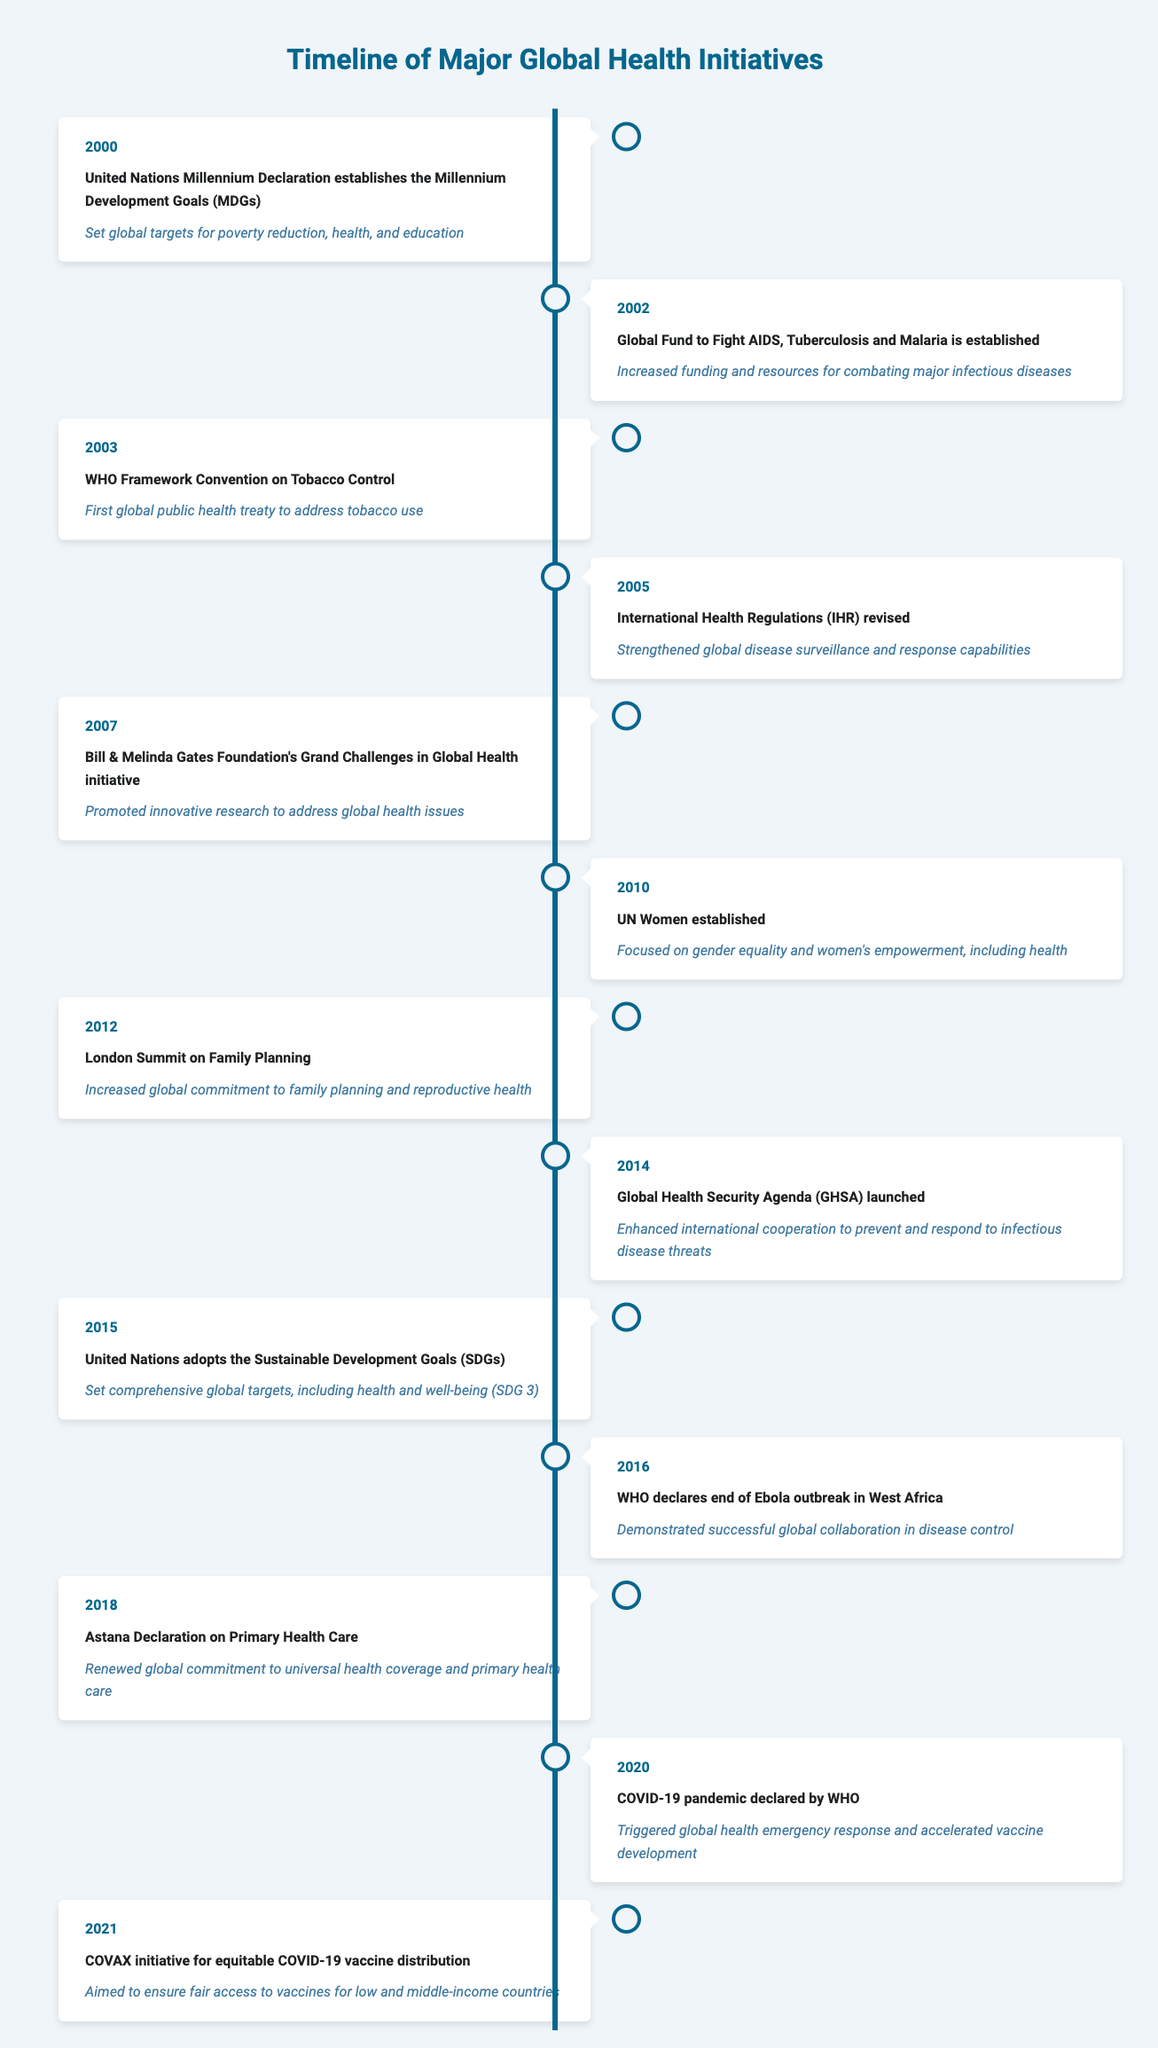What major global health initiative was established in 2000? The table indicates that in 2000, the "United Nations Millennium Declaration establishes the Millennium Development Goals (MDGs)" as a major global health initiative.
Answer: United Nations Millennium Declaration establishes the Millennium Development Goals (MDGs) What impact did the Global Fund to Fight AIDS, Tuberculosis and Malaria have? According to the entry for 2002, the impact was "Increased funding and resources for combating major infectious diseases."
Answer: Increased funding and resources for combating major infectious diseases In what year did the WHO declare the end of the Ebola outbreak? The table shows that the WHO declared the end of the Ebola outbreak in West Africa in 2016.
Answer: 2016 True or False: The Global Health Security Agenda was launched in 2012. The table states the Global Health Security Agenda was launched in 2014, therefore the statement is false.
Answer: False What is the difference in years between the establishment of UN Women and the establishment of the Global Fund? UN Women was established in 2010 and the Global Fund was established in 2002. The difference is 2010 - 2002 = 8 years.
Answer: 8 years How many major global health initiatives were established between 2000 and 2015? There are 8 initiatives listed between the years 2000 and 2015 (including events from 2000 to 2015), which can be counted directly from the rows.
Answer: 8 What is the impact of the Astana Declaration on Primary Health Care? The table states that its impact is "Renewed global commitment to universal health coverage and primary health care."
Answer: Renewed global commitment to universal health coverage and primary health care Was the COVAX initiative launched before the COVID-19 pandemic was declared? The COVAX initiative was launched in 2021, after the COVID-19 pandemic was declared in 2020, thus the statement is false.
Answer: False List the three major health initiatives that occurred in the years ending with a '0'. The initiatives in years ending with '0' are: "UN Women established" in 2010, "COVID-19 pandemic declared by WHO" in 2020.
Answer: UN Women established, COVID-19 pandemic declared by WHO 